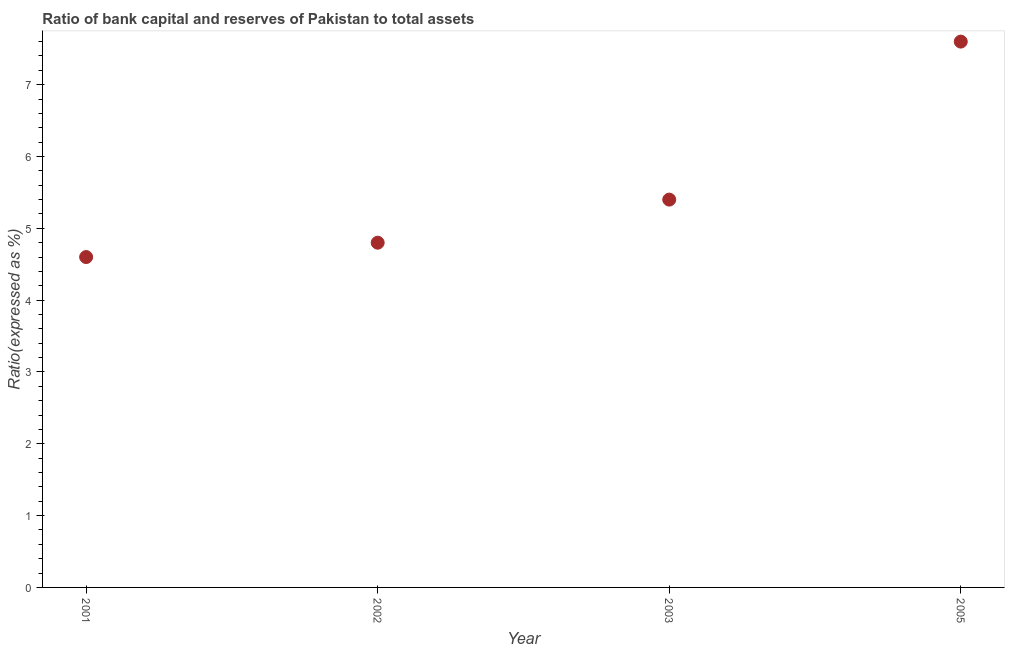In which year was the bank capital to assets ratio maximum?
Provide a succinct answer. 2005. In which year was the bank capital to assets ratio minimum?
Your answer should be very brief. 2001. What is the sum of the bank capital to assets ratio?
Give a very brief answer. 22.4. What is the ratio of the bank capital to assets ratio in 2002 to that in 2005?
Ensure brevity in your answer.  0.63. What is the difference between the highest and the second highest bank capital to assets ratio?
Offer a terse response. 2.2. How many dotlines are there?
Keep it short and to the point. 1. What is the difference between two consecutive major ticks on the Y-axis?
Provide a short and direct response. 1. Are the values on the major ticks of Y-axis written in scientific E-notation?
Your answer should be compact. No. Does the graph contain grids?
Your answer should be compact. No. What is the title of the graph?
Your response must be concise. Ratio of bank capital and reserves of Pakistan to total assets. What is the label or title of the Y-axis?
Provide a succinct answer. Ratio(expressed as %). What is the Ratio(expressed as %) in 2005?
Give a very brief answer. 7.6. What is the difference between the Ratio(expressed as %) in 2001 and 2002?
Your answer should be compact. -0.2. What is the difference between the Ratio(expressed as %) in 2002 and 2003?
Your answer should be very brief. -0.6. What is the difference between the Ratio(expressed as %) in 2003 and 2005?
Your response must be concise. -2.2. What is the ratio of the Ratio(expressed as %) in 2001 to that in 2002?
Your answer should be very brief. 0.96. What is the ratio of the Ratio(expressed as %) in 2001 to that in 2003?
Provide a succinct answer. 0.85. What is the ratio of the Ratio(expressed as %) in 2001 to that in 2005?
Give a very brief answer. 0.6. What is the ratio of the Ratio(expressed as %) in 2002 to that in 2003?
Ensure brevity in your answer.  0.89. What is the ratio of the Ratio(expressed as %) in 2002 to that in 2005?
Your answer should be very brief. 0.63. What is the ratio of the Ratio(expressed as %) in 2003 to that in 2005?
Your answer should be very brief. 0.71. 